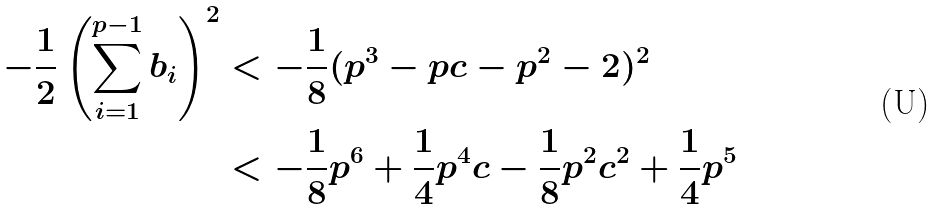<formula> <loc_0><loc_0><loc_500><loc_500>- \frac { 1 } { 2 } \left ( \sum _ { i = 1 } ^ { p - 1 } b _ { i } \right ) ^ { 2 } & < - \frac { 1 } { 8 } ( p ^ { 3 } - p c - p ^ { 2 } - 2 ) ^ { 2 } \\ & < - \frac { 1 } { 8 } p ^ { 6 } + \frac { 1 } { 4 } p ^ { 4 } c - \frac { 1 } { 8 } p ^ { 2 } c ^ { 2 } + \frac { 1 } { 4 } p ^ { 5 }</formula> 